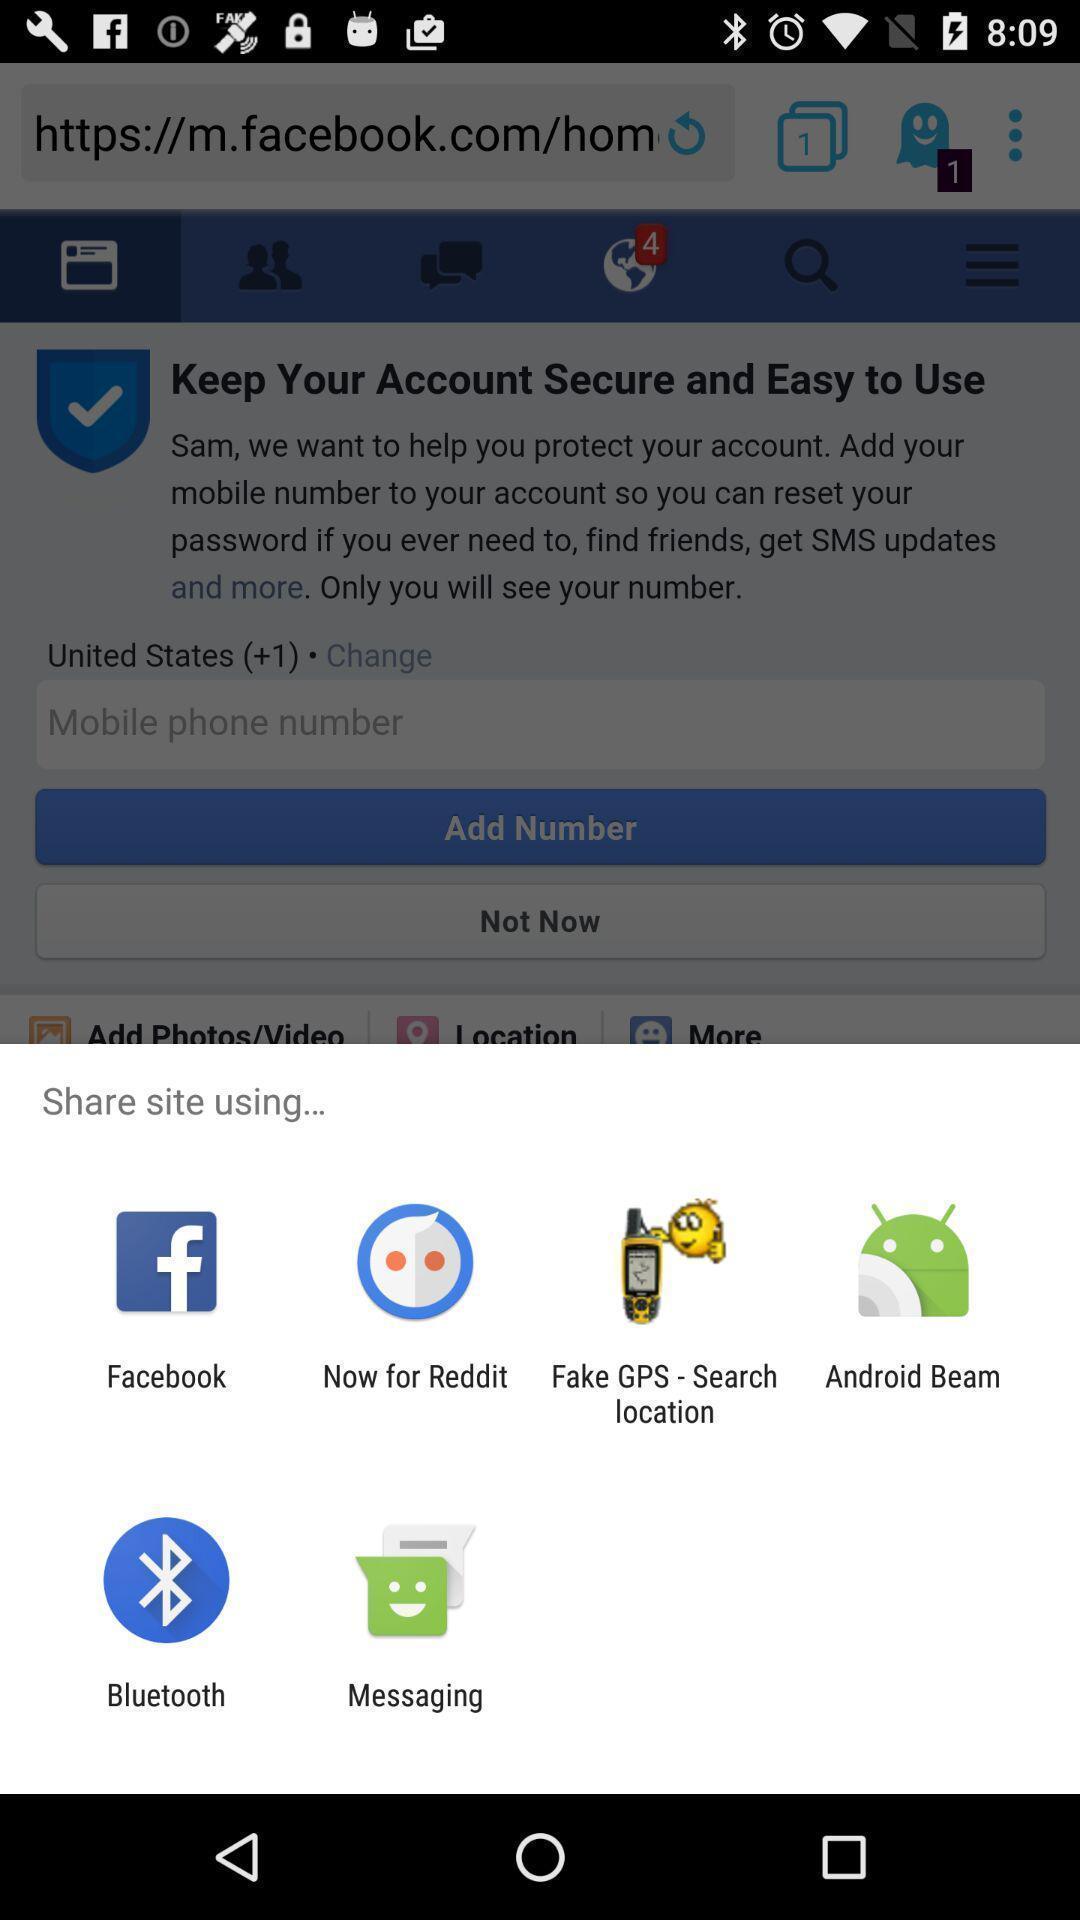Tell me about the visual elements in this screen capture. Pop up of sharing data with different social media. 